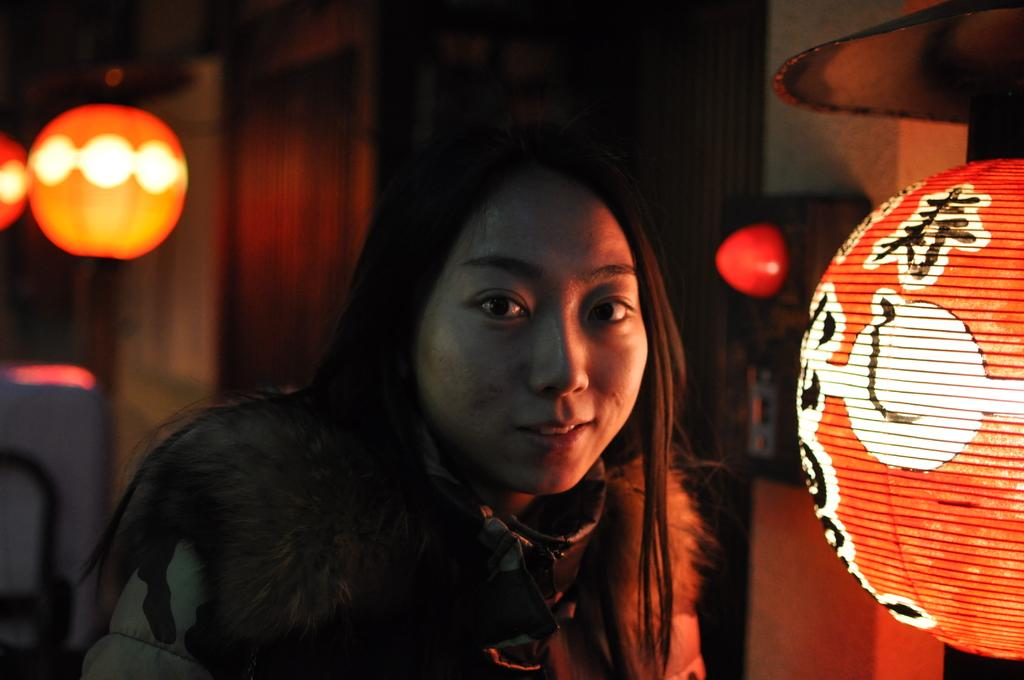Who is the main subject in the image? There is a girl in the image. What objects can be seen in the image besides the girl? There are lamps in the image. What type of zipper is the girl attempting to fix in the image? There is no zipper present in the image, and the girl is not attempting to fix anything. 